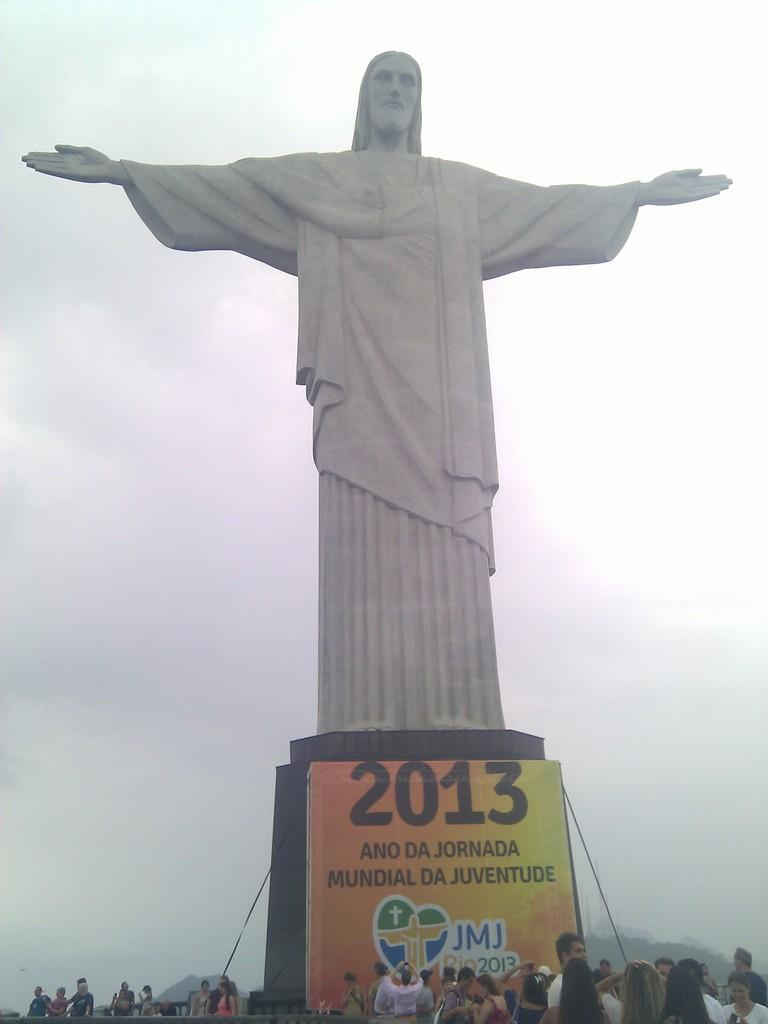<image>
Summarize the visual content of the image. A towering statue has a banner with 2013 hanging from it. 